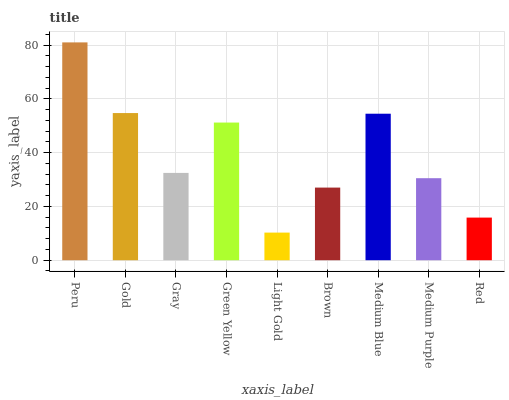Is Light Gold the minimum?
Answer yes or no. Yes. Is Peru the maximum?
Answer yes or no. Yes. Is Gold the minimum?
Answer yes or no. No. Is Gold the maximum?
Answer yes or no. No. Is Peru greater than Gold?
Answer yes or no. Yes. Is Gold less than Peru?
Answer yes or no. Yes. Is Gold greater than Peru?
Answer yes or no. No. Is Peru less than Gold?
Answer yes or no. No. Is Gray the high median?
Answer yes or no. Yes. Is Gray the low median?
Answer yes or no. Yes. Is Gold the high median?
Answer yes or no. No. Is Gold the low median?
Answer yes or no. No. 